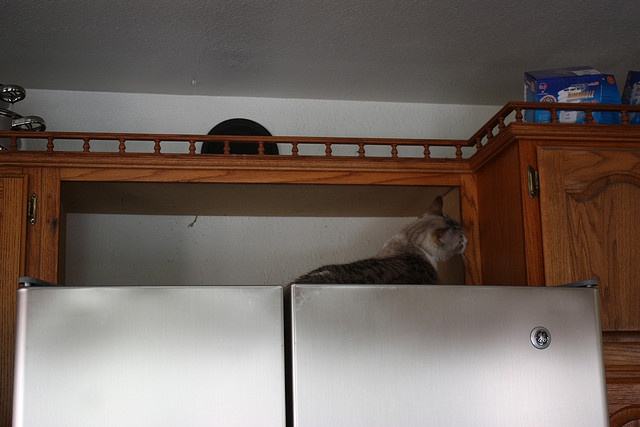Describe the objects in this image and their specific colors. I can see refrigerator in black, lightgray, darkgray, and gray tones, refrigerator in black, lightgray, darkgray, and gray tones, and cat in black, gray, and maroon tones in this image. 